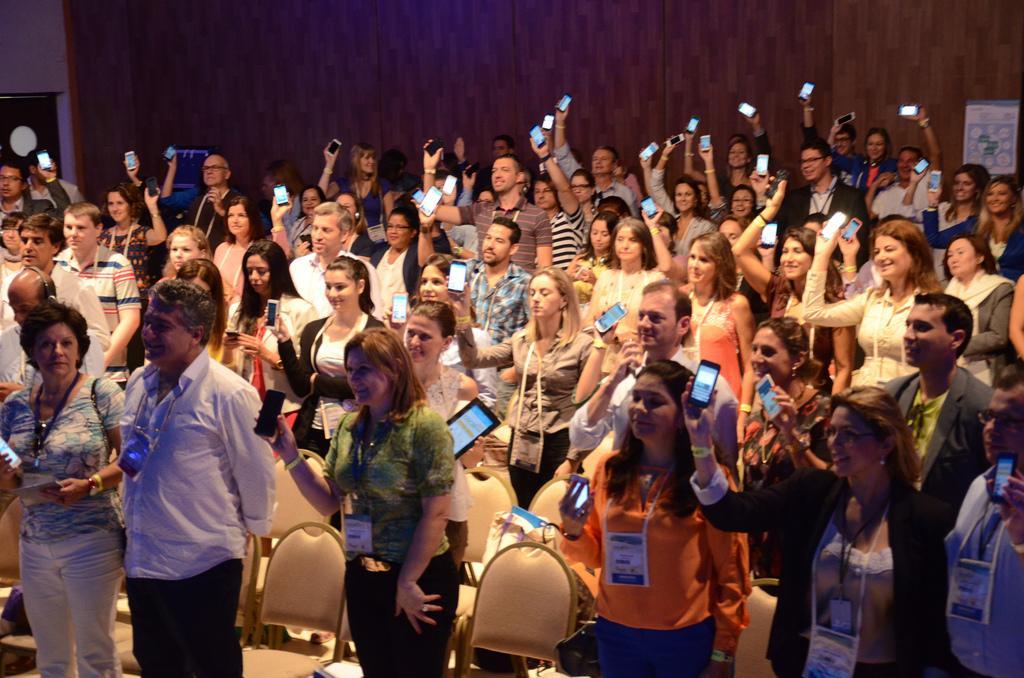Can you describe this image briefly? In this image I can see number of people are standing and I can also see most of them are holding mobile phones. In the front I can see few empty chairs and I can also see one person is holding a tablet. On the right side of this image I can see a white colour poster on the wall and on the left side I can see a black colour thing. I can also see few people are wearing ID cards. 